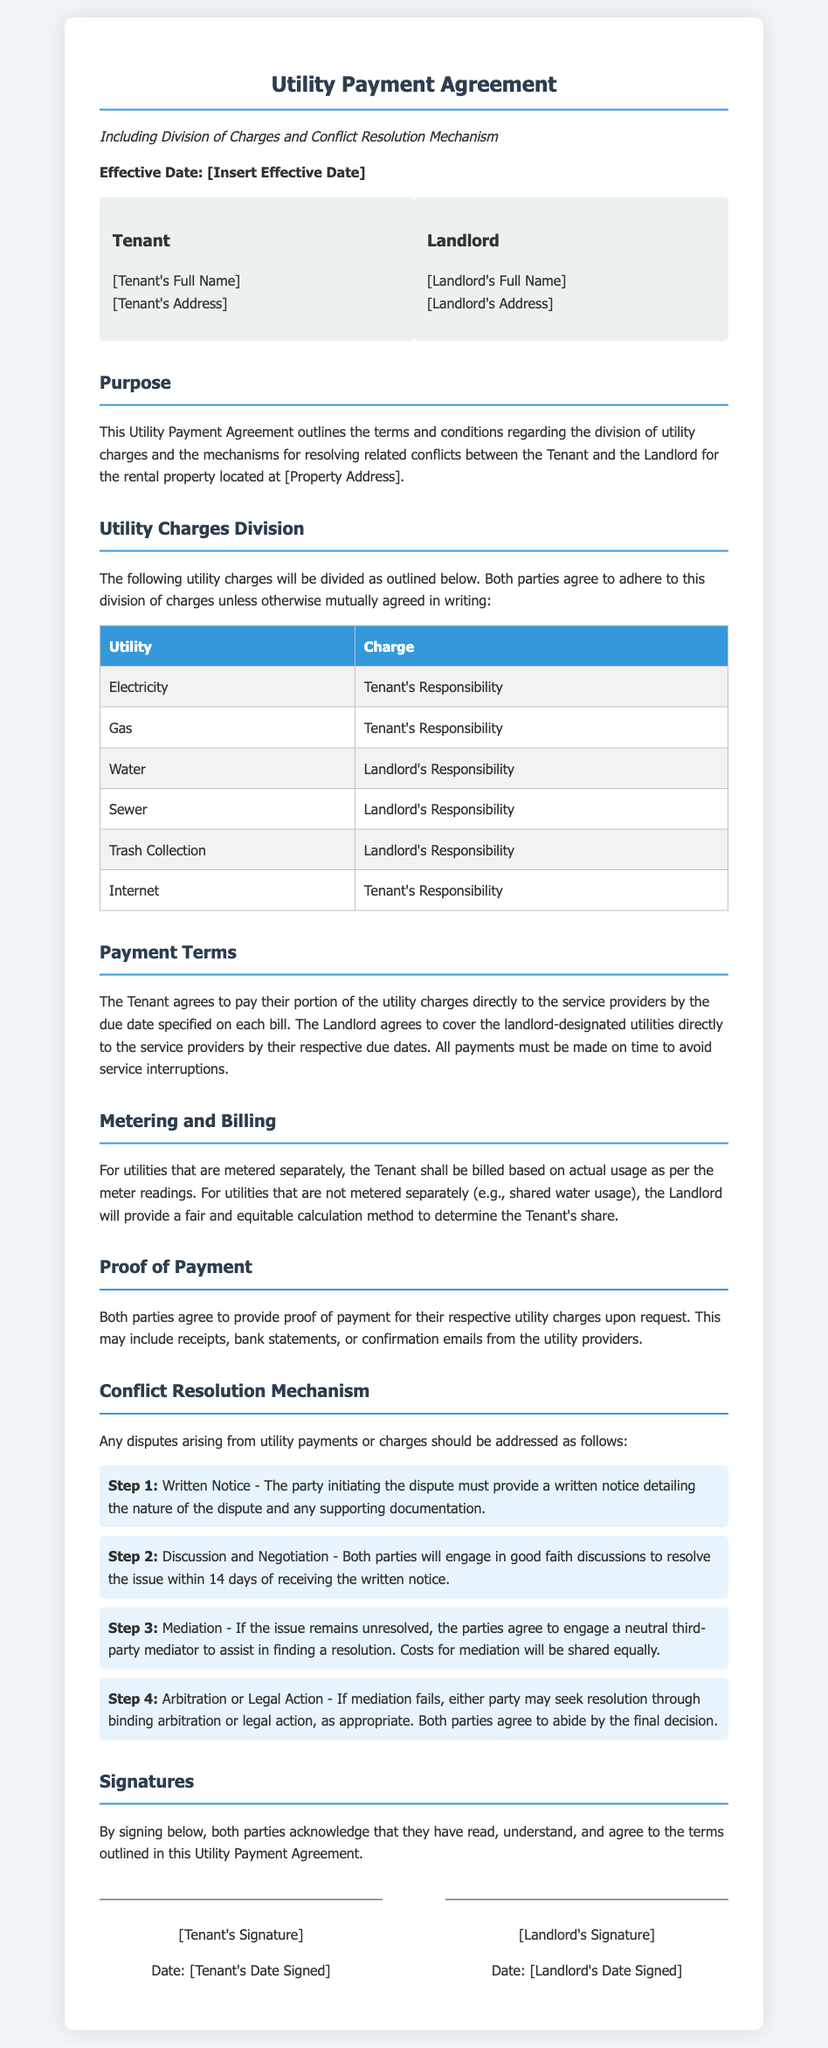What is the effective date of the agreement? The effective date serves as the starting point of the agreement but it is currently a placeholder.
Answer: [Insert Effective Date] Who is responsible for the electricity charge? The document specifies the responsibilities regarding utility charges, indicating who pays what.
Answer: Tenant's Responsibility Which utilities are covered by the landlord? The division of responsibilities for utility payments outlines the landlord's obligations.
Answer: Water, Sewer, Trash Collection What step follows written notice in the conflict resolution mechanism? Understanding the order of steps in the conflict resolution process can clarify how disputes should be handled.
Answer: Discussion and Negotiation What is the method of resolution if mediation fails? The document states the next steps if initial conflict resolution efforts are unsuccessful.
Answer: Binding arbitration or legal action 